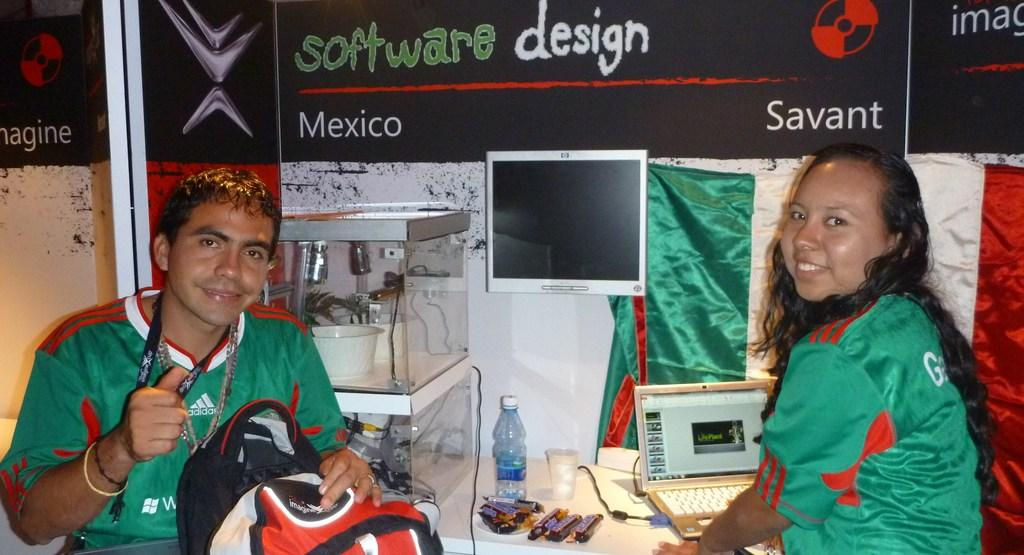Provide a one-sentence caption for the provided image. Two people are sitting at a desk and there is a sign above them that says software design in green and white letters. 